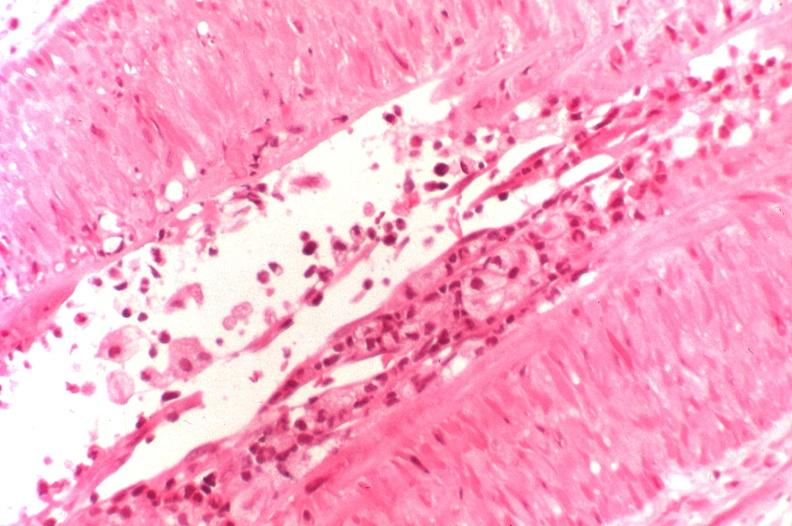does this image show kidney transplant rejection?
Answer the question using a single word or phrase. Yes 